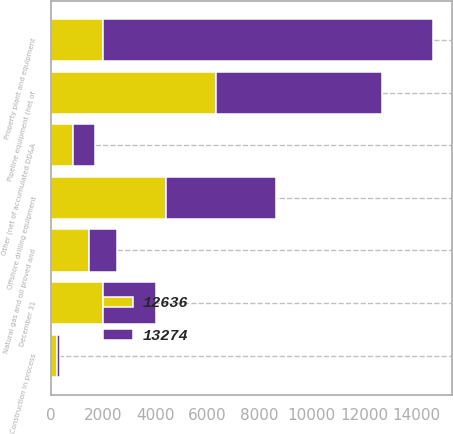<chart> <loc_0><loc_0><loc_500><loc_500><stacked_bar_chart><ecel><fcel>December 31<fcel>Pipeline equipment (net of<fcel>Offshore drilling equipment<fcel>Natural gas and oil proved and<fcel>Other (net of accumulated DD&A<fcel>Construction in process<fcel>Property plant and equipment<nl><fcel>13274<fcel>2010<fcel>6358<fcel>4242<fcel>1099<fcel>822<fcel>115<fcel>12636<nl><fcel>12636<fcel>2009<fcel>6325<fcel>4405<fcel>1450<fcel>860<fcel>234<fcel>2009<nl></chart> 